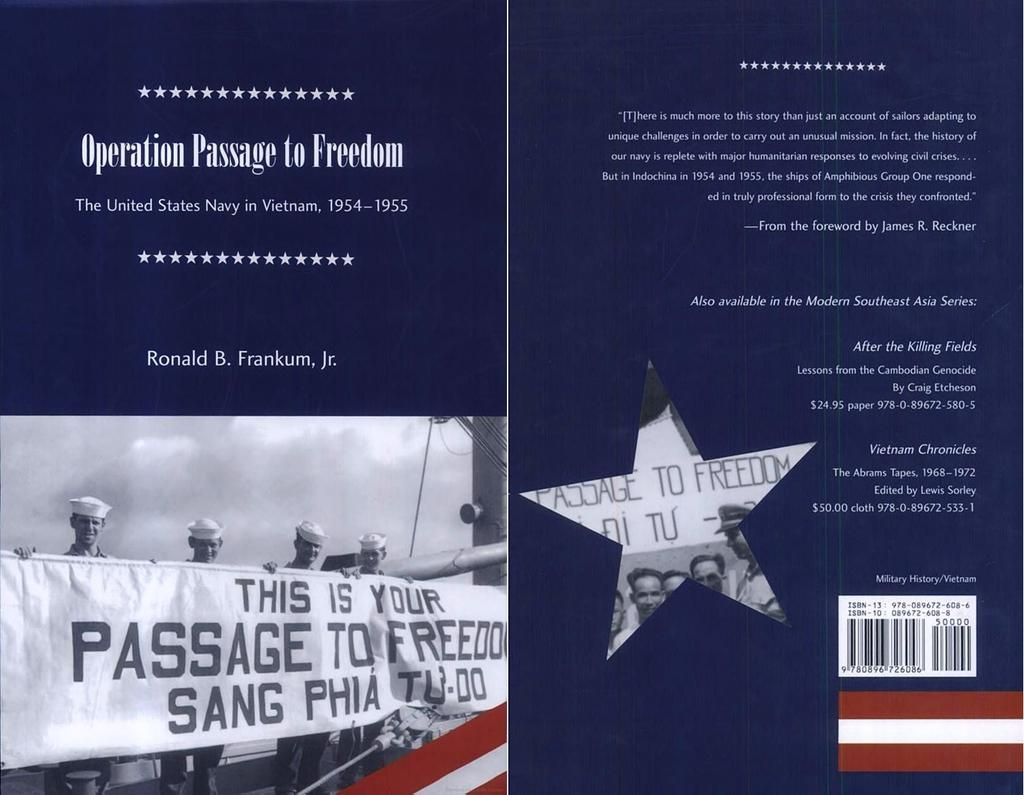<image>
Render a clear and concise summary of the photo. A blue flyer with the title Operation Passage to Freedom. 